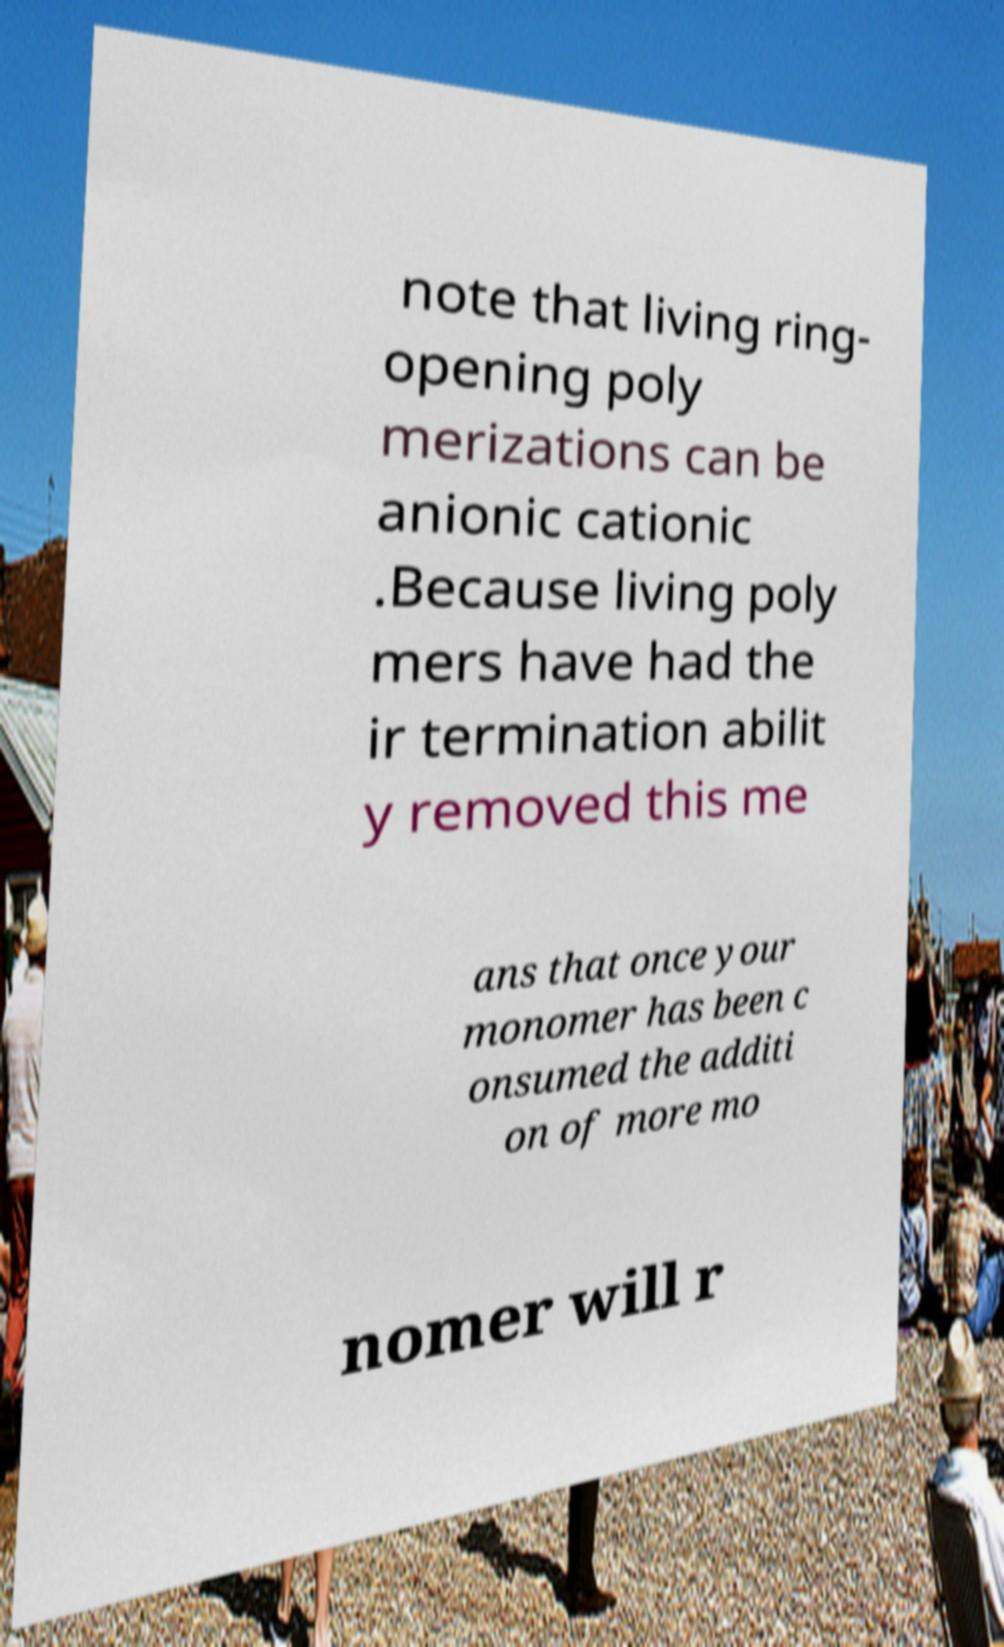What messages or text are displayed in this image? I need them in a readable, typed format. note that living ring- opening poly merizations can be anionic cationic .Because living poly mers have had the ir termination abilit y removed this me ans that once your monomer has been c onsumed the additi on of more mo nomer will r 